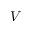<formula> <loc_0><loc_0><loc_500><loc_500>V</formula> 